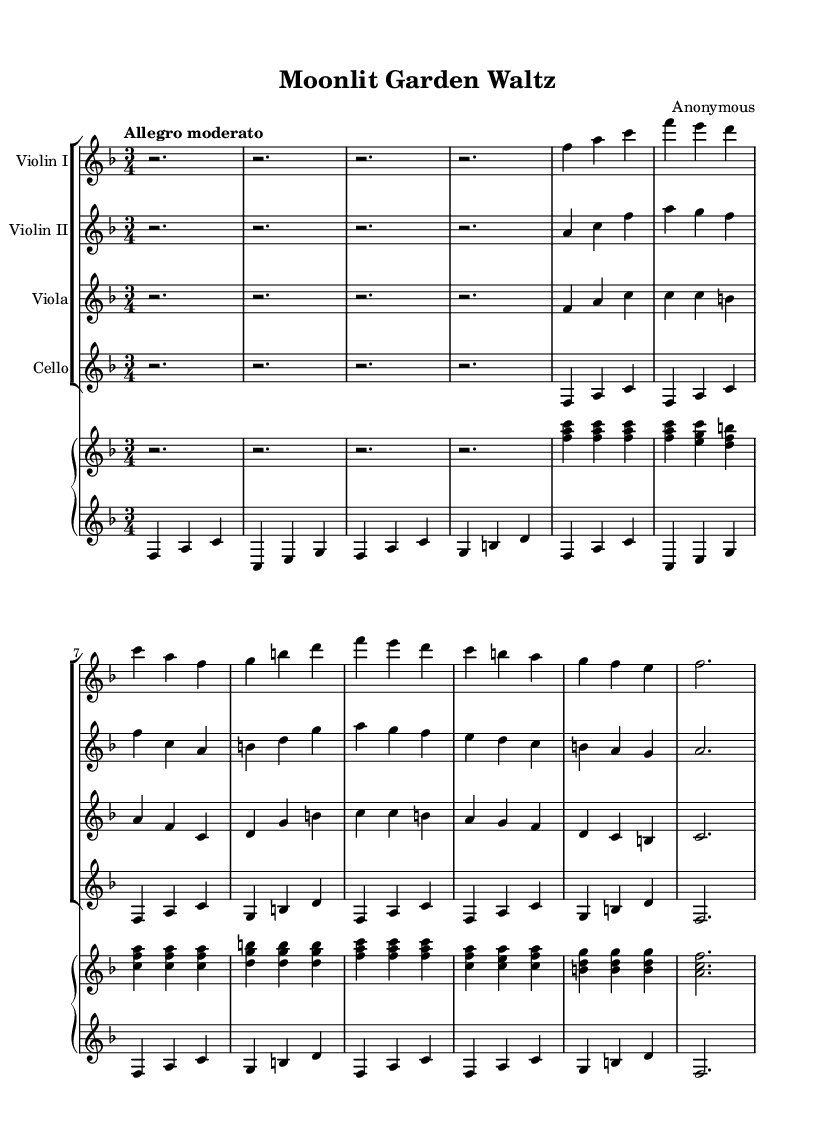What is the key signature of this music? The key signature indicated in the sheet music is F major, which has one flat (B flat). This can be identified in the key signature section of the score.
Answer: F major What is the time signature of this music? The time signature is shown at the beginning of the score as 3/4, indicating that there are three beats in each measure and a quarter note receives one beat.
Answer: 3/4 What is the tempo marking for this piece? The tempo marking in the score indicates "Allegro moderato," which suggests a moderately fast pace. This information is found written above the measure.
Answer: Allegro moderato How many measures are in the introduction section? The introduction consists of 4 measures, as indicated by the notation at the beginning of the score. Each measure is counted until the first section starts.
Answer: 4 In the A section of this music, what is the first note played by the violin I? The first note played by the Violin I in the A section is F. This can be located at the start of the A section after the introduction.
Answer: F What instruments are featured in this composition? The score indicates four string instruments (Violin I, Violin II, Viola, and Cello) along with a piano, which are listed in the staff group section at the beginning of the score.
Answer: Violin I, Violin II, Viola, Cello, and Piano What is the chord played in the first measure of the piano's upper staff? The first measure in the piano's upper staff shows the chord F-A-C, indicating it is an F major chord. This is determined by reading the notes stacked in that measure.
Answer: F A C 